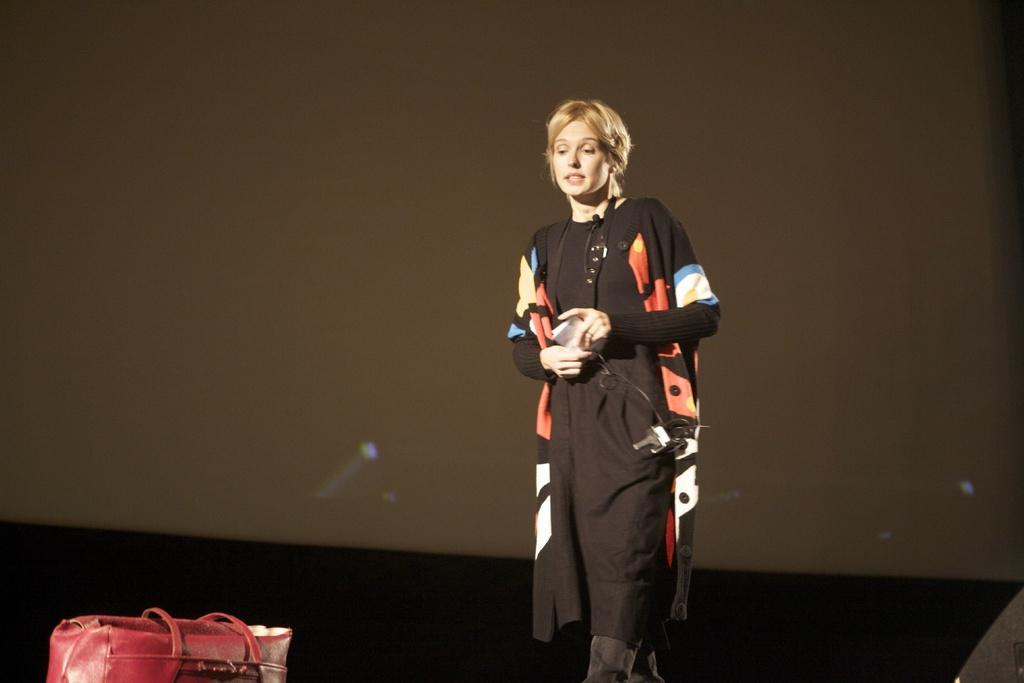In one or two sentences, can you explain what this image depicts? In this picture we can see woman holding paper in her hands and walking towards the red color bag and in background we can see wall. 